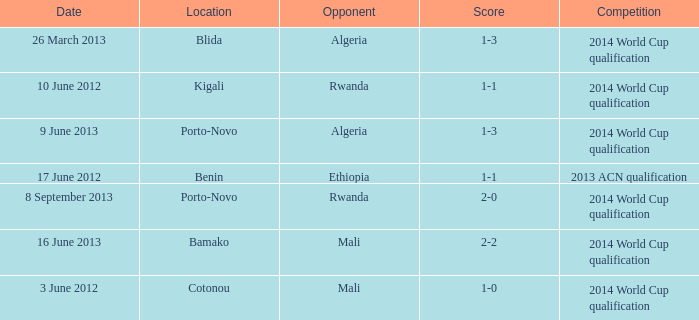What is the result of the match in porto-novo with algeria as the opposing team? 1-3. 